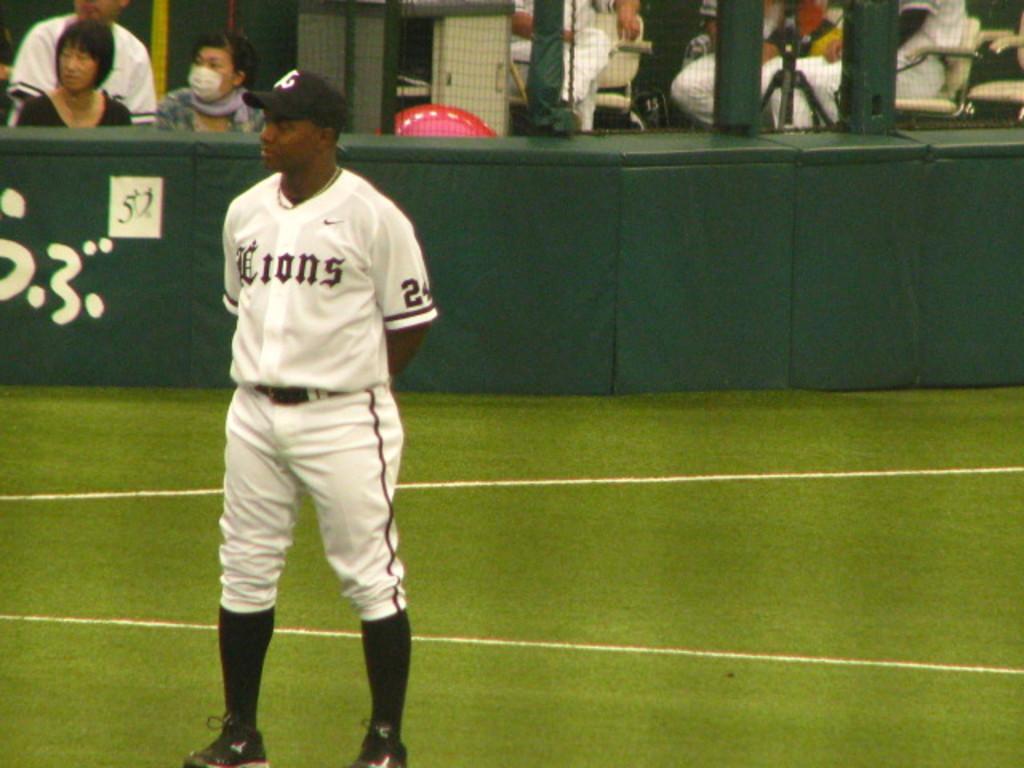What team does the man play for?
Your answer should be very brief. Lions. What number is the player wearing?
Keep it short and to the point. 24. 